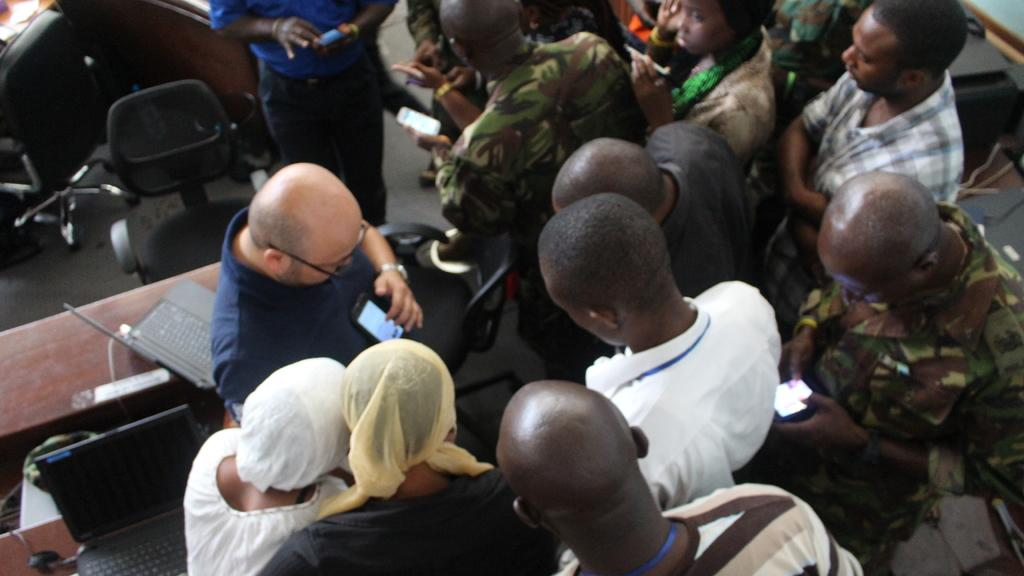What can be seen on the floor in the image? There are persons in different color dresses on a floor. What objects are on the left side of the image? There are laptops on tables on the left side. What type of furniture is visible in the background? There are chairs in the background on the floor. Where is the nest located in the image? There is no nest present in the image. How many kittens can be seen playing with the crib in the image? There are no kittens or crib present in the image. 